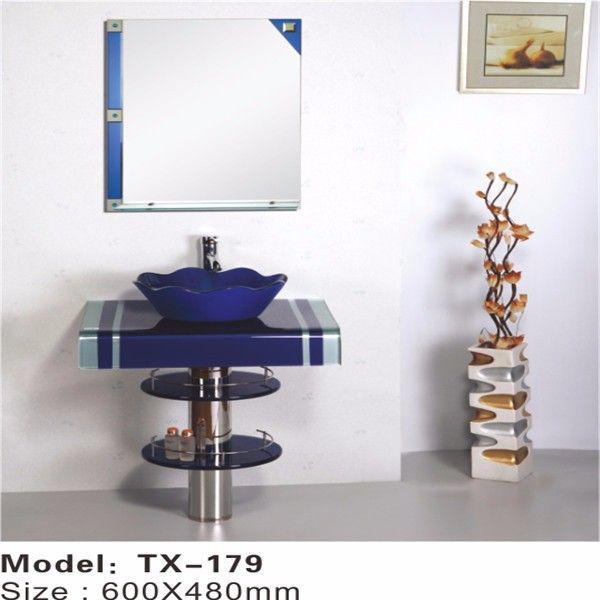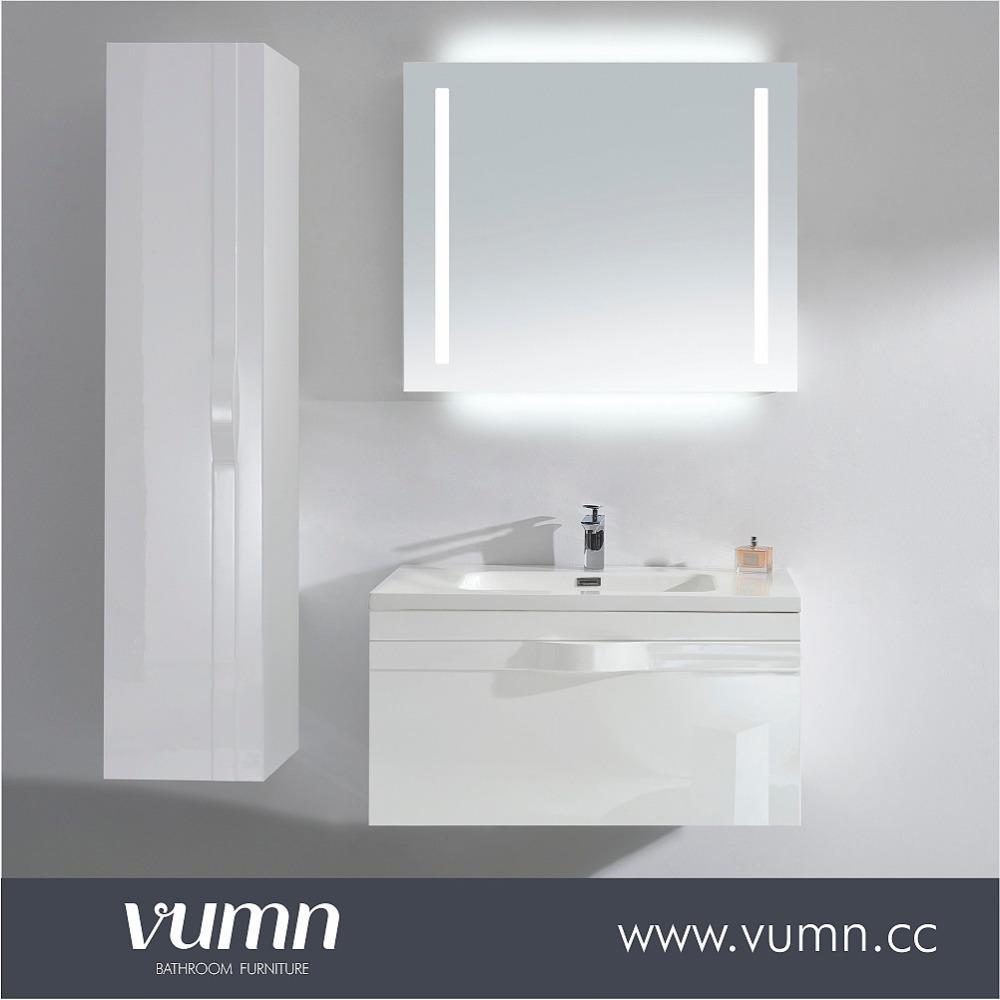The first image is the image on the left, the second image is the image on the right. Evaluate the accuracy of this statement regarding the images: "Neither picture contains a mirror that is shaped like a circle or an oval.". Is it true? Answer yes or no. Yes. The first image is the image on the left, the second image is the image on the right. Evaluate the accuracy of this statement regarding the images: "There is a frame on the wall in the image on the left.". Is it true? Answer yes or no. Yes. 